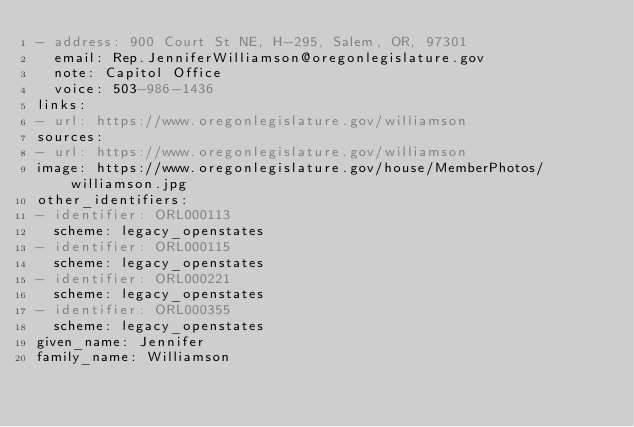Convert code to text. <code><loc_0><loc_0><loc_500><loc_500><_YAML_>- address: 900 Court St NE, H-295, Salem, OR, 97301
  email: Rep.JenniferWilliamson@oregonlegislature.gov
  note: Capitol Office
  voice: 503-986-1436
links:
- url: https://www.oregonlegislature.gov/williamson
sources:
- url: https://www.oregonlegislature.gov/williamson
image: https://www.oregonlegislature.gov/house/MemberPhotos/williamson.jpg
other_identifiers:
- identifier: ORL000113
  scheme: legacy_openstates
- identifier: ORL000115
  scheme: legacy_openstates
- identifier: ORL000221
  scheme: legacy_openstates
- identifier: ORL000355
  scheme: legacy_openstates
given_name: Jennifer
family_name: Williamson
</code> 